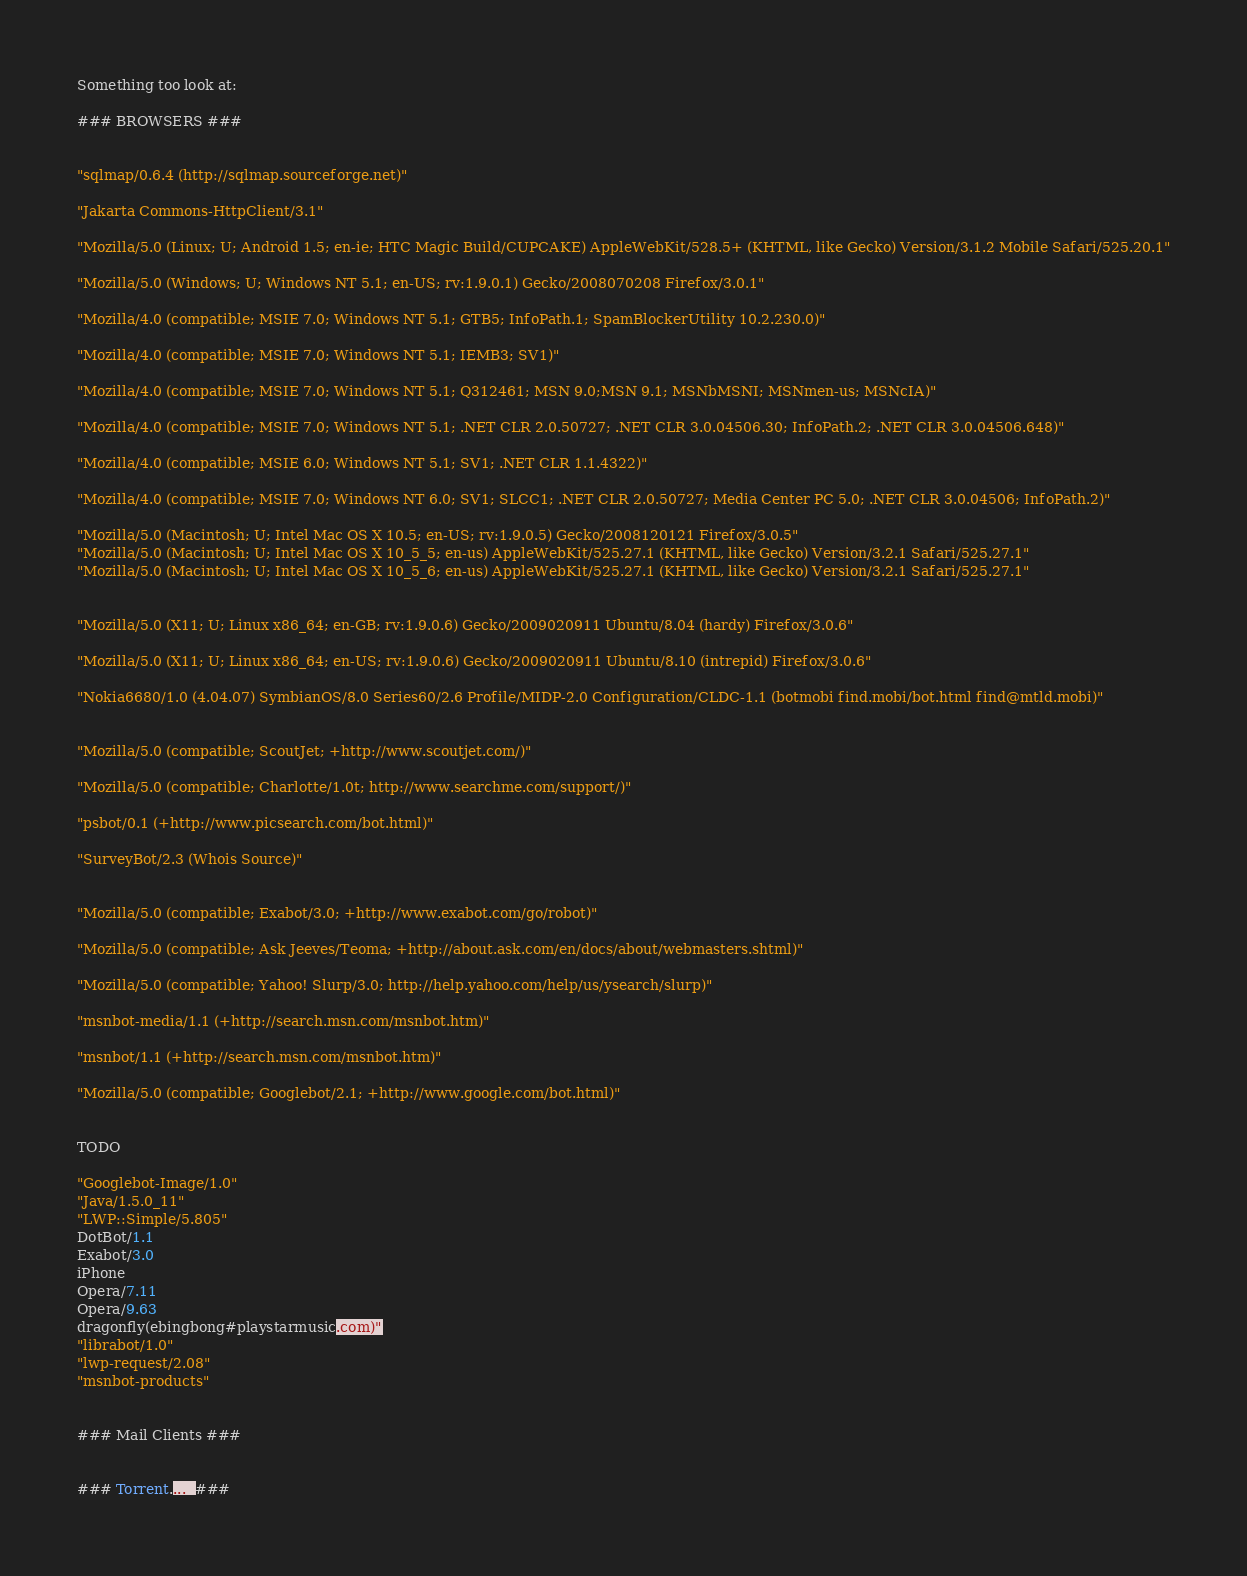Convert code to text. <code><loc_0><loc_0><loc_500><loc_500><_SML_>


Something too look at:

### BROWSERS ###


"sqlmap/0.6.4 (http://sqlmap.sourceforge.net)"

"Jakarta Commons-HttpClient/3.1"

"Mozilla/5.0 (Linux; U; Android 1.5; en-ie; HTC Magic Build/CUPCAKE) AppleWebKit/528.5+ (KHTML, like Gecko) Version/3.1.2 Mobile Safari/525.20.1"

"Mozilla/5.0 (Windows; U; Windows NT 5.1; en-US; rv:1.9.0.1) Gecko/2008070208 Firefox/3.0.1"

"Mozilla/4.0 (compatible; MSIE 7.0; Windows NT 5.1; GTB5; InfoPath.1; SpamBlockerUtility 10.2.230.0)"

"Mozilla/4.0 (compatible; MSIE 7.0; Windows NT 5.1; IEMB3; SV1)"

"Mozilla/4.0 (compatible; MSIE 7.0; Windows NT 5.1; Q312461; MSN 9.0;MSN 9.1; MSNbMSNI; MSNmen-us; MSNcIA)"

"Mozilla/4.0 (compatible; MSIE 7.0; Windows NT 5.1; .NET CLR 2.0.50727; .NET CLR 3.0.04506.30; InfoPath.2; .NET CLR 3.0.04506.648)"

"Mozilla/4.0 (compatible; MSIE 6.0; Windows NT 5.1; SV1; .NET CLR 1.1.4322)"

"Mozilla/4.0 (compatible; MSIE 7.0; Windows NT 6.0; SV1; SLCC1; .NET CLR 2.0.50727; Media Center PC 5.0; .NET CLR 3.0.04506; InfoPath.2)"

"Mozilla/5.0 (Macintosh; U; Intel Mac OS X 10.5; en-US; rv:1.9.0.5) Gecko/2008120121 Firefox/3.0.5"
"Mozilla/5.0 (Macintosh; U; Intel Mac OS X 10_5_5; en-us) AppleWebKit/525.27.1 (KHTML, like Gecko) Version/3.2.1 Safari/525.27.1"
"Mozilla/5.0 (Macintosh; U; Intel Mac OS X 10_5_6; en-us) AppleWebKit/525.27.1 (KHTML, like Gecko) Version/3.2.1 Safari/525.27.1"


"Mozilla/5.0 (X11; U; Linux x86_64; en-GB; rv:1.9.0.6) Gecko/2009020911 Ubuntu/8.04 (hardy) Firefox/3.0.6"

"Mozilla/5.0 (X11; U; Linux x86_64; en-US; rv:1.9.0.6) Gecko/2009020911 Ubuntu/8.10 (intrepid) Firefox/3.0.6"

"Nokia6680/1.0 (4.04.07) SymbianOS/8.0 Series60/2.6 Profile/MIDP-2.0 Configuration/CLDC-1.1 (botmobi find.mobi/bot.html find@mtld.mobi)"


"Mozilla/5.0 (compatible; ScoutJet; +http://www.scoutjet.com/)"

"Mozilla/5.0 (compatible; Charlotte/1.0t; http://www.searchme.com/support/)"

"psbot/0.1 (+http://www.picsearch.com/bot.html)"

"SurveyBot/2.3 (Whois Source)"


"Mozilla/5.0 (compatible; Exabot/3.0; +http://www.exabot.com/go/robot)"

"Mozilla/5.0 (compatible; Ask Jeeves/Teoma; +http://about.ask.com/en/docs/about/webmasters.shtml)"

"Mozilla/5.0 (compatible; Yahoo! Slurp/3.0; http://help.yahoo.com/help/us/ysearch/slurp)"

"msnbot-media/1.1 (+http://search.msn.com/msnbot.htm)"

"msnbot/1.1 (+http://search.msn.com/msnbot.htm)"

"Mozilla/5.0 (compatible; Googlebot/2.1; +http://www.google.com/bot.html)"


TODO

"Googlebot-Image/1.0"
"Java/1.5.0_11"
"LWP::Simple/5.805"
DotBot/1.1
Exabot/3.0
iPhone
Opera/7.11
Opera/9.63
dragonfly(ebingbong#playstarmusic.com)"
"librabot/1.0"
"lwp-request/2.08"
"msnbot-products"


### Mail Clients ###


### Torrent....  ###









</code> 